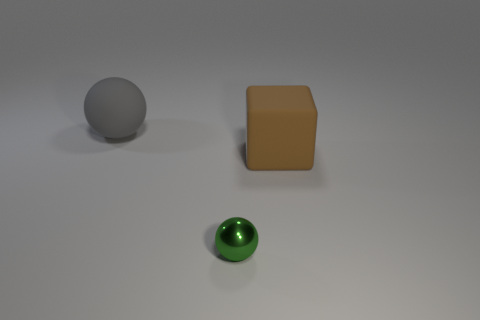Do the sphere in front of the large brown block and the big brown block have the same material?
Give a very brief answer. No. How many things are both to the left of the brown block and behind the small green metallic object?
Your answer should be very brief. 1. There is a large object left of the big matte thing in front of the large matte thing on the left side of the small green metal sphere; what color is it?
Offer a terse response. Gray. How many other objects are the same shape as the large brown object?
Provide a succinct answer. 0. There is a big matte object that is right of the small metallic object; are there any big objects that are behind it?
Make the answer very short. Yes. What number of shiny things are either gray balls or small cyan cubes?
Offer a terse response. 0. There is a object that is left of the big block and in front of the big gray object; what is it made of?
Offer a terse response. Metal. There is a sphere on the right side of the sphere that is left of the shiny ball; is there a big ball on the right side of it?
Your answer should be compact. No. Is there any other thing that is the same material as the green sphere?
Offer a terse response. No. What is the shape of the gray object that is made of the same material as the cube?
Offer a very short reply. Sphere. 